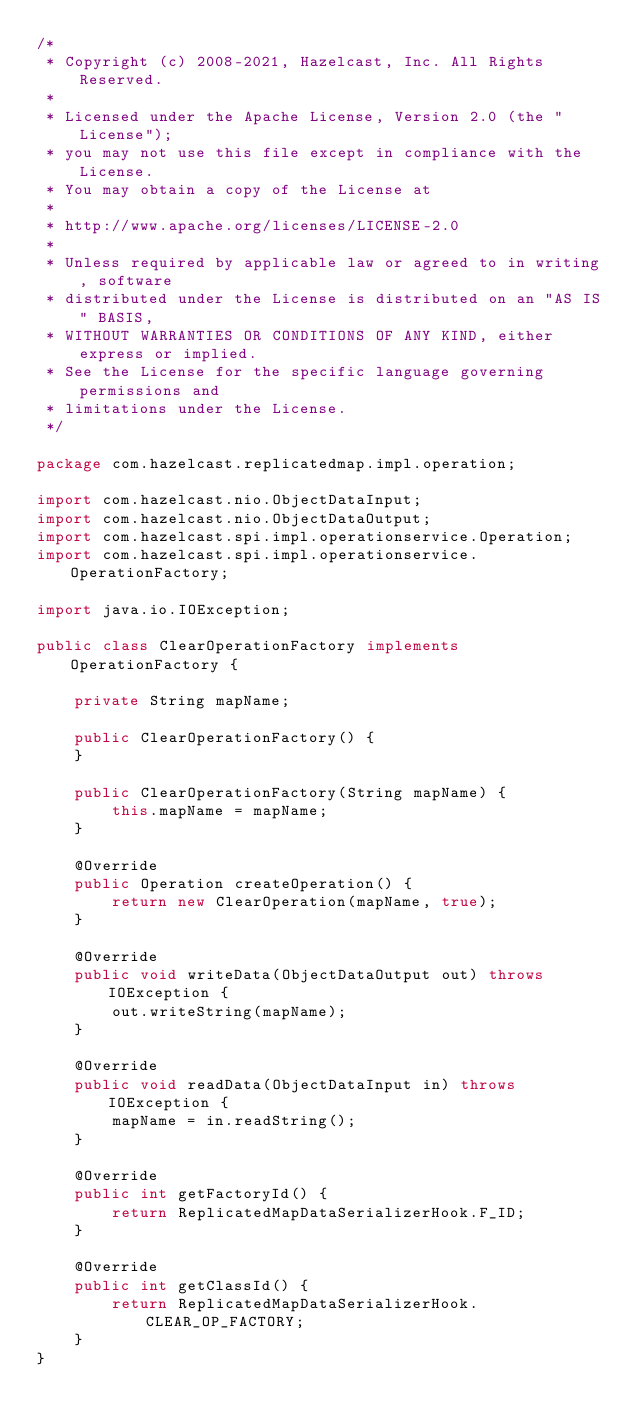Convert code to text. <code><loc_0><loc_0><loc_500><loc_500><_Java_>/*
 * Copyright (c) 2008-2021, Hazelcast, Inc. All Rights Reserved.
 *
 * Licensed under the Apache License, Version 2.0 (the "License");
 * you may not use this file except in compliance with the License.
 * You may obtain a copy of the License at
 *
 * http://www.apache.org/licenses/LICENSE-2.0
 *
 * Unless required by applicable law or agreed to in writing, software
 * distributed under the License is distributed on an "AS IS" BASIS,
 * WITHOUT WARRANTIES OR CONDITIONS OF ANY KIND, either express or implied.
 * See the License for the specific language governing permissions and
 * limitations under the License.
 */

package com.hazelcast.replicatedmap.impl.operation;

import com.hazelcast.nio.ObjectDataInput;
import com.hazelcast.nio.ObjectDataOutput;
import com.hazelcast.spi.impl.operationservice.Operation;
import com.hazelcast.spi.impl.operationservice.OperationFactory;

import java.io.IOException;

public class ClearOperationFactory implements OperationFactory {

    private String mapName;

    public ClearOperationFactory() {
    }

    public ClearOperationFactory(String mapName) {
        this.mapName = mapName;
    }

    @Override
    public Operation createOperation() {
        return new ClearOperation(mapName, true);
    }

    @Override
    public void writeData(ObjectDataOutput out) throws IOException {
        out.writeString(mapName);
    }

    @Override
    public void readData(ObjectDataInput in) throws IOException {
        mapName = in.readString();
    }

    @Override
    public int getFactoryId() {
        return ReplicatedMapDataSerializerHook.F_ID;
    }

    @Override
    public int getClassId() {
        return ReplicatedMapDataSerializerHook.CLEAR_OP_FACTORY;
    }
}

</code> 